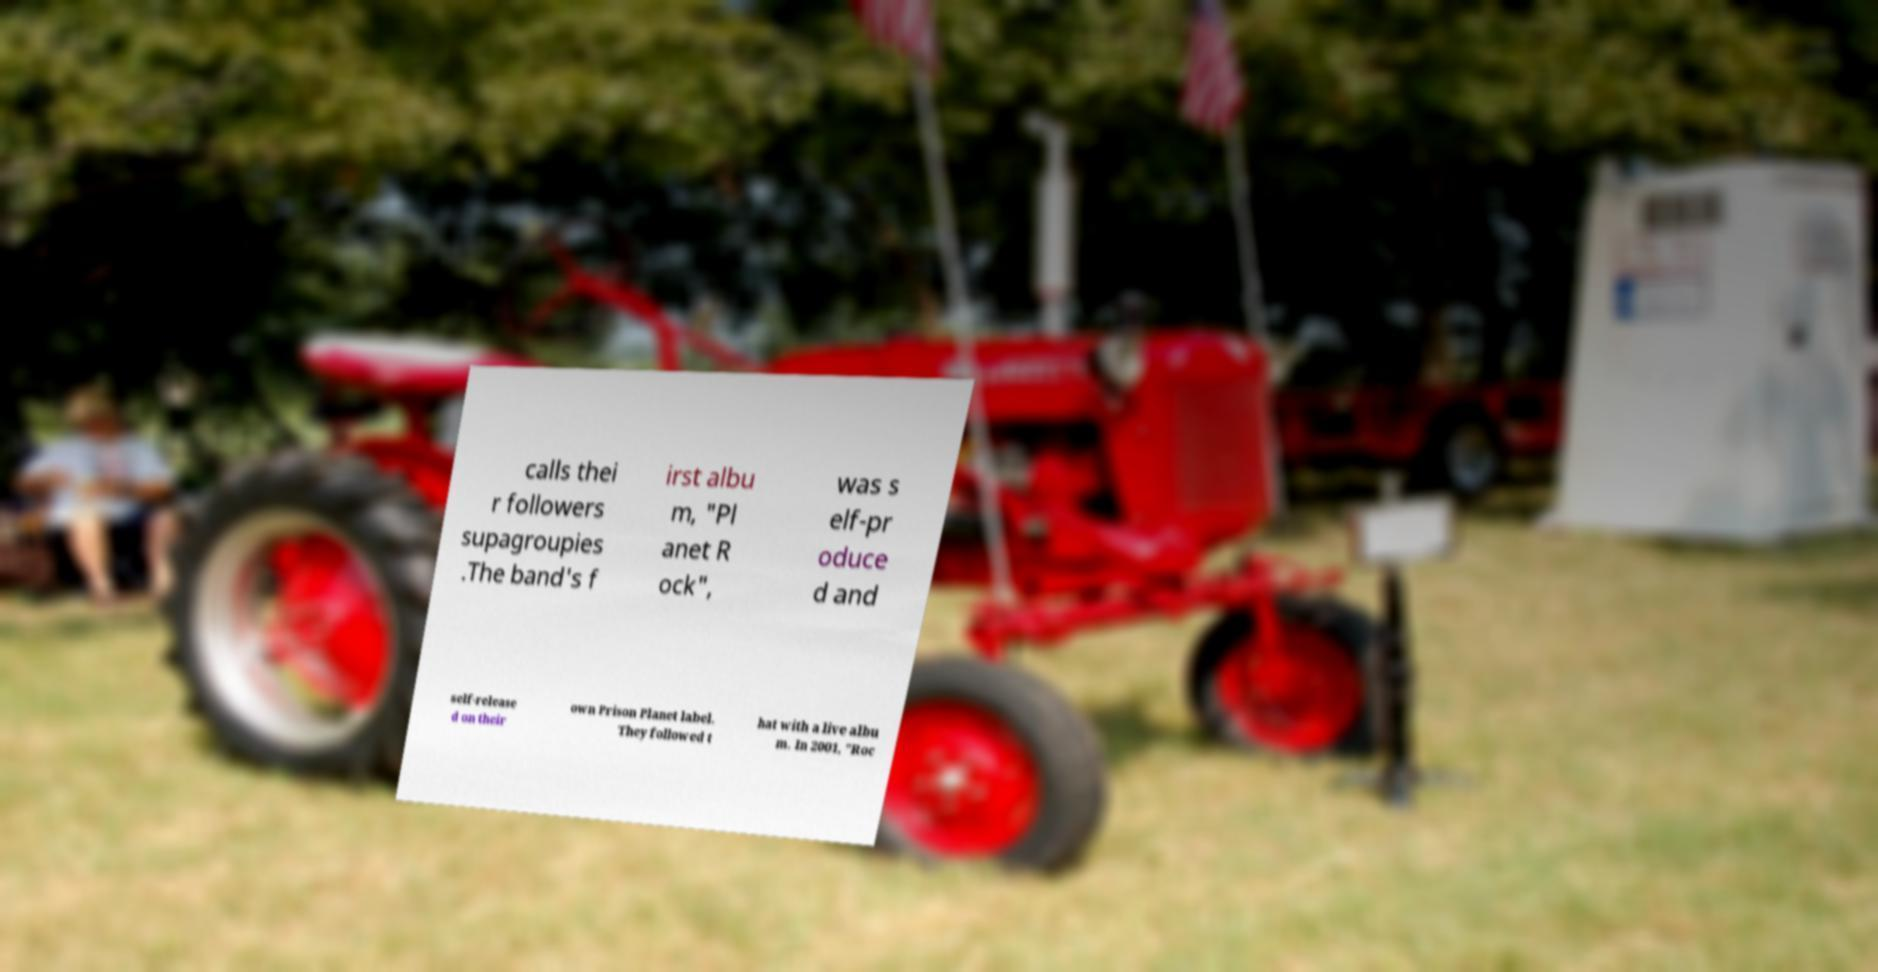Could you assist in decoding the text presented in this image and type it out clearly? calls thei r followers supagroupies .The band's f irst albu m, "Pl anet R ock", was s elf-pr oduce d and self-release d on their own Prison Planet label. They followed t hat with a live albu m. In 2001, "Roc 